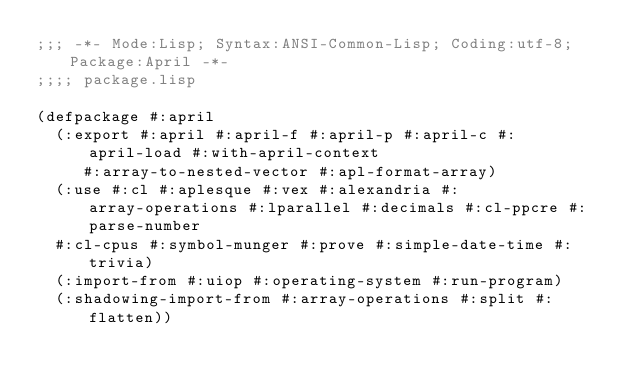<code> <loc_0><loc_0><loc_500><loc_500><_Lisp_>;;; -*- Mode:Lisp; Syntax:ANSI-Common-Lisp; Coding:utf-8; Package:April -*-
;;;; package.lisp

(defpackage #:april
  (:export #:april #:april-f #:april-p #:april-c #:april-load #:with-april-context
	   #:array-to-nested-vector #:apl-format-array)
  (:use #:cl #:aplesque #:vex #:alexandria #:array-operations #:lparallel #:decimals #:cl-ppcre #:parse-number
	#:cl-cpus #:symbol-munger #:prove #:simple-date-time #:trivia)
  (:import-from #:uiop #:operating-system #:run-program)
  (:shadowing-import-from #:array-operations #:split #:flatten))
</code> 